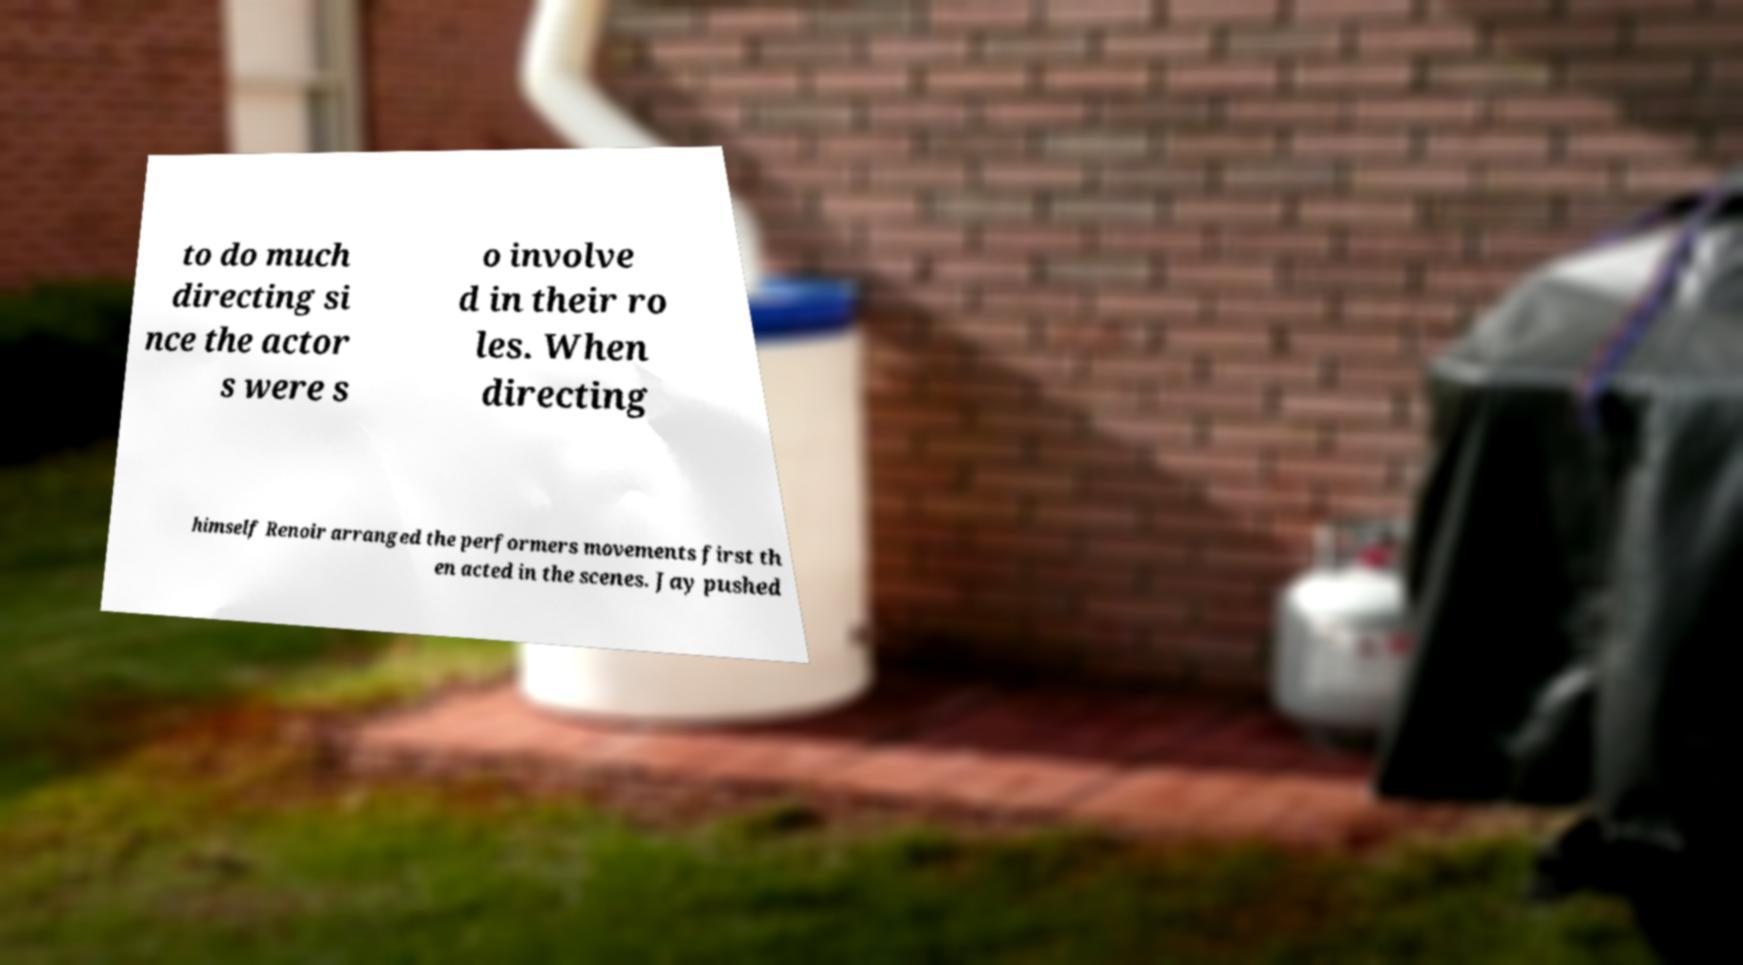Can you read and provide the text displayed in the image?This photo seems to have some interesting text. Can you extract and type it out for me? to do much directing si nce the actor s were s o involve d in their ro les. When directing himself Renoir arranged the performers movements first th en acted in the scenes. Jay pushed 